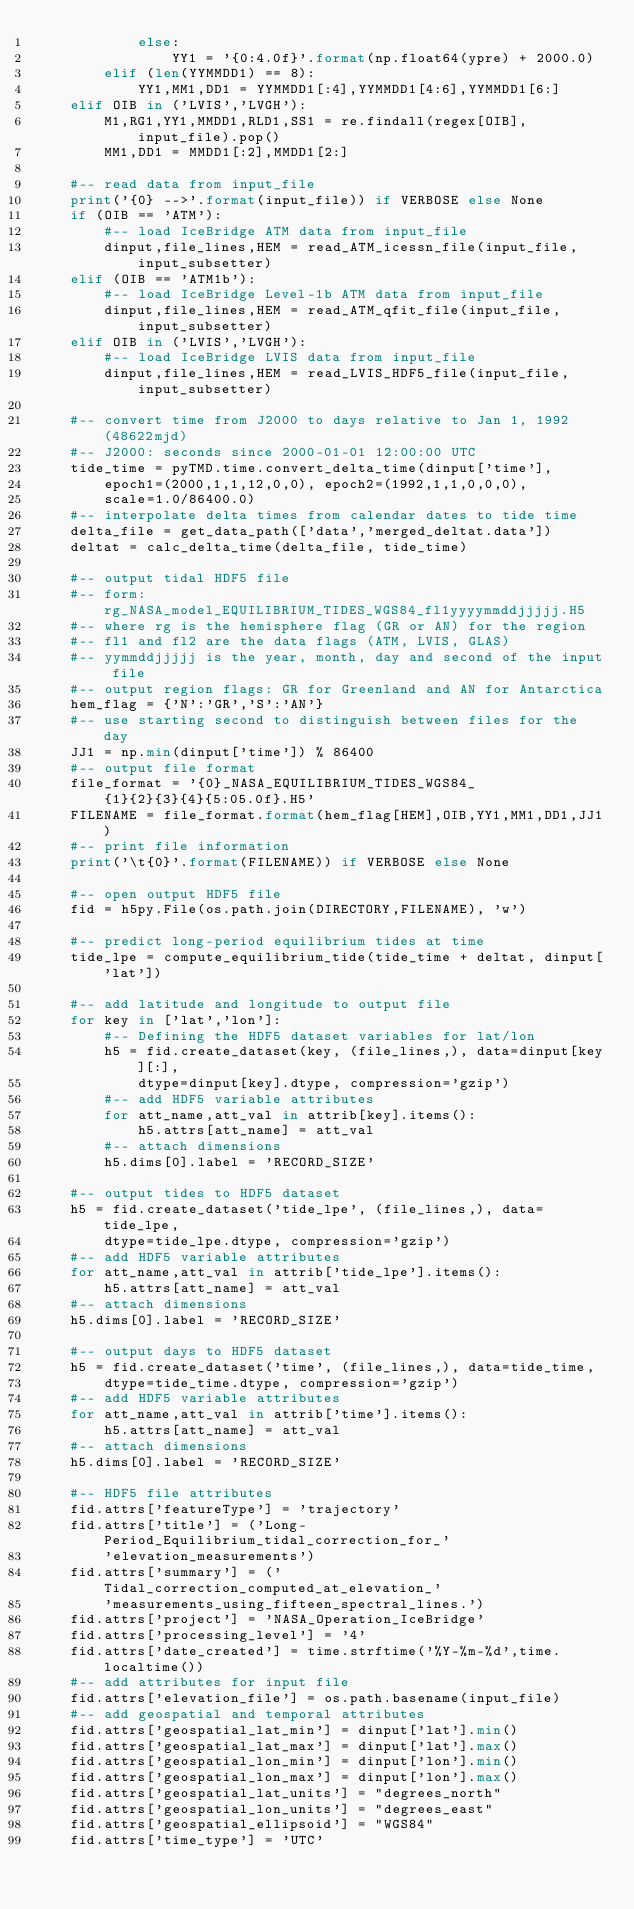<code> <loc_0><loc_0><loc_500><loc_500><_Python_>            else:
                YY1 = '{0:4.0f}'.format(np.float64(ypre) + 2000.0)
        elif (len(YYMMDD1) == 8):
            YY1,MM1,DD1 = YYMMDD1[:4],YYMMDD1[4:6],YYMMDD1[6:]
    elif OIB in ('LVIS','LVGH'):
        M1,RG1,YY1,MMDD1,RLD1,SS1 = re.findall(regex[OIB], input_file).pop()
        MM1,DD1 = MMDD1[:2],MMDD1[2:]

    #-- read data from input_file
    print('{0} -->'.format(input_file)) if VERBOSE else None
    if (OIB == 'ATM'):
        #-- load IceBridge ATM data from input_file
        dinput,file_lines,HEM = read_ATM_icessn_file(input_file,input_subsetter)
    elif (OIB == 'ATM1b'):
        #-- load IceBridge Level-1b ATM data from input_file
        dinput,file_lines,HEM = read_ATM_qfit_file(input_file,input_subsetter)
    elif OIB in ('LVIS','LVGH'):
        #-- load IceBridge LVIS data from input_file
        dinput,file_lines,HEM = read_LVIS_HDF5_file(input_file,input_subsetter)

    #-- convert time from J2000 to days relative to Jan 1, 1992 (48622mjd)
    #-- J2000: seconds since 2000-01-01 12:00:00 UTC
    tide_time = pyTMD.time.convert_delta_time(dinput['time'],
        epoch1=(2000,1,1,12,0,0), epoch2=(1992,1,1,0,0,0),
        scale=1.0/86400.0)
    #-- interpolate delta times from calendar dates to tide time
    delta_file = get_data_path(['data','merged_deltat.data'])
    deltat = calc_delta_time(delta_file, tide_time)

    #-- output tidal HDF5 file
    #-- form: rg_NASA_model_EQUILIBRIUM_TIDES_WGS84_fl1yyyymmddjjjjj.H5
    #-- where rg is the hemisphere flag (GR or AN) for the region
    #-- fl1 and fl2 are the data flags (ATM, LVIS, GLAS)
    #-- yymmddjjjjj is the year, month, day and second of the input file
    #-- output region flags: GR for Greenland and AN for Antarctica
    hem_flag = {'N':'GR','S':'AN'}
    #-- use starting second to distinguish between files for the day
    JJ1 = np.min(dinput['time']) % 86400
    #-- output file format
    file_format = '{0}_NASA_EQUILIBRIUM_TIDES_WGS84_{1}{2}{3}{4}{5:05.0f}.H5'
    FILENAME = file_format.format(hem_flag[HEM],OIB,YY1,MM1,DD1,JJ1)
    #-- print file information
    print('\t{0}'.format(FILENAME)) if VERBOSE else None

    #-- open output HDF5 file
    fid = h5py.File(os.path.join(DIRECTORY,FILENAME), 'w')

    #-- predict long-period equilibrium tides at time
    tide_lpe = compute_equilibrium_tide(tide_time + deltat, dinput['lat'])

    #-- add latitude and longitude to output file
    for key in ['lat','lon']:
        #-- Defining the HDF5 dataset variables for lat/lon
        h5 = fid.create_dataset(key, (file_lines,), data=dinput[key][:],
            dtype=dinput[key].dtype, compression='gzip')
        #-- add HDF5 variable attributes
        for att_name,att_val in attrib[key].items():
            h5.attrs[att_name] = att_val
        #-- attach dimensions
        h5.dims[0].label = 'RECORD_SIZE'

    #-- output tides to HDF5 dataset
    h5 = fid.create_dataset('tide_lpe', (file_lines,), data=tide_lpe,
        dtype=tide_lpe.dtype, compression='gzip')
    #-- add HDF5 variable attributes
    for att_name,att_val in attrib['tide_lpe'].items():
        h5.attrs[att_name] = att_val
    #-- attach dimensions
    h5.dims[0].label = 'RECORD_SIZE'

    #-- output days to HDF5 dataset
    h5 = fid.create_dataset('time', (file_lines,), data=tide_time,
        dtype=tide_time.dtype, compression='gzip')
    #-- add HDF5 variable attributes
    for att_name,att_val in attrib['time'].items():
        h5.attrs[att_name] = att_val
    #-- attach dimensions
    h5.dims[0].label = 'RECORD_SIZE'

    #-- HDF5 file attributes
    fid.attrs['featureType'] = 'trajectory'
    fid.attrs['title'] = ('Long-Period_Equilibrium_tidal_correction_for_'
        'elevation_measurements')
    fid.attrs['summary'] = ('Tidal_correction_computed_at_elevation_'
        'measurements_using_fifteen_spectral_lines.')
    fid.attrs['project'] = 'NASA_Operation_IceBridge'
    fid.attrs['processing_level'] = '4'
    fid.attrs['date_created'] = time.strftime('%Y-%m-%d',time.localtime())
    #-- add attributes for input file
    fid.attrs['elevation_file'] = os.path.basename(input_file)
    #-- add geospatial and temporal attributes
    fid.attrs['geospatial_lat_min'] = dinput['lat'].min()
    fid.attrs['geospatial_lat_max'] = dinput['lat'].max()
    fid.attrs['geospatial_lon_min'] = dinput['lon'].min()
    fid.attrs['geospatial_lon_max'] = dinput['lon'].max()
    fid.attrs['geospatial_lat_units'] = "degrees_north"
    fid.attrs['geospatial_lon_units'] = "degrees_east"
    fid.attrs['geospatial_ellipsoid'] = "WGS84"
    fid.attrs['time_type'] = 'UTC'</code> 